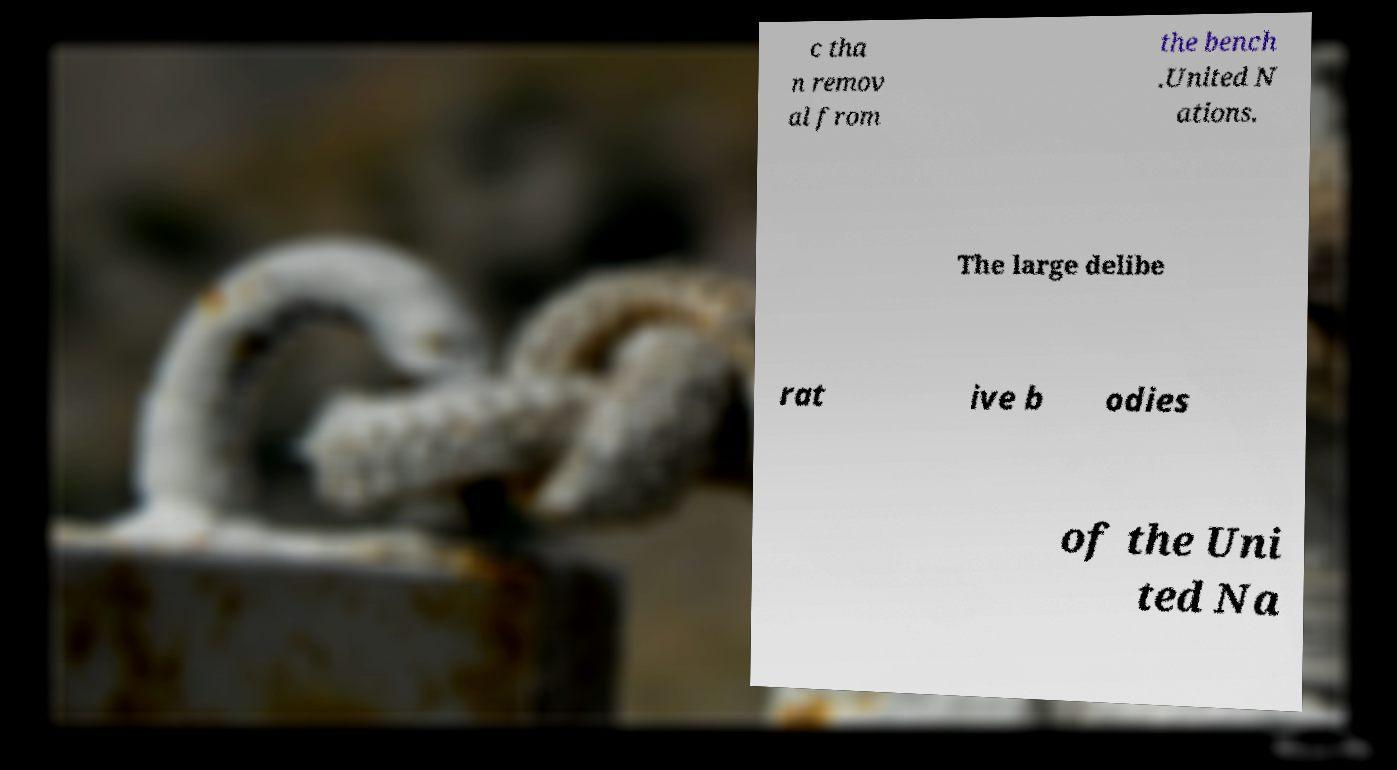I need the written content from this picture converted into text. Can you do that? c tha n remov al from the bench .United N ations. The large delibe rat ive b odies of the Uni ted Na 